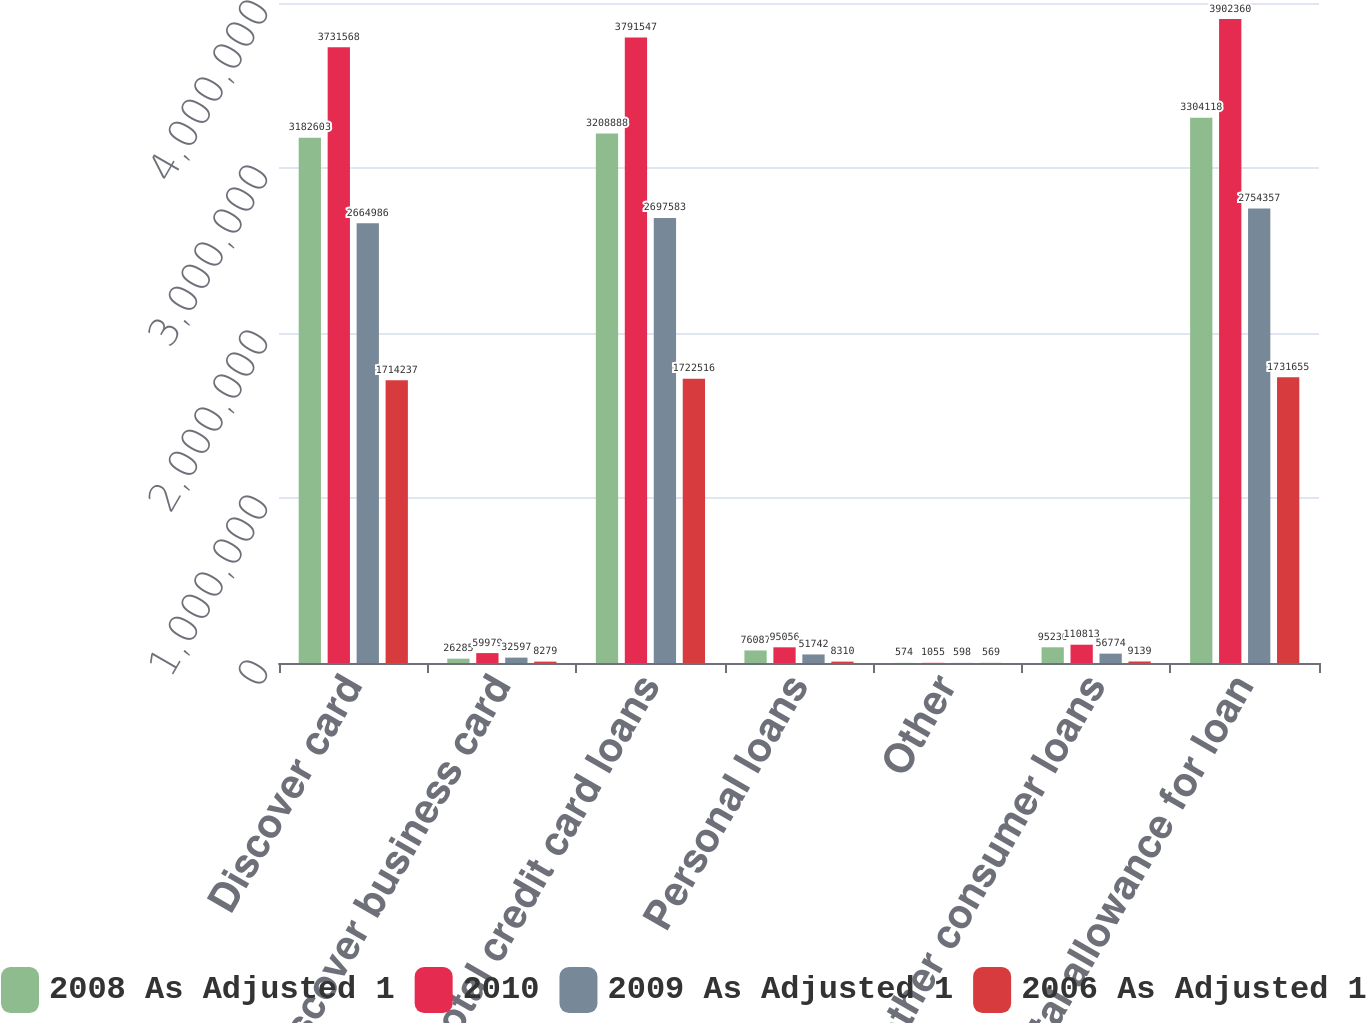Convert chart to OTSL. <chart><loc_0><loc_0><loc_500><loc_500><stacked_bar_chart><ecel><fcel>Discover card<fcel>Discover business card<fcel>Total credit card loans<fcel>Personal loans<fcel>Other<fcel>Total other consumer loans<fcel>Total allowance for loan<nl><fcel>2008 As Adjusted 1<fcel>3.1826e+06<fcel>26285<fcel>3.20889e+06<fcel>76087<fcel>574<fcel>95230<fcel>3.30412e+06<nl><fcel>2010<fcel>3.73157e+06<fcel>59979<fcel>3.79155e+06<fcel>95056<fcel>1055<fcel>110813<fcel>3.90236e+06<nl><fcel>2009 As Adjusted 1<fcel>2.66499e+06<fcel>32597<fcel>2.69758e+06<fcel>51742<fcel>598<fcel>56774<fcel>2.75436e+06<nl><fcel>2006 As Adjusted 1<fcel>1.71424e+06<fcel>8279<fcel>1.72252e+06<fcel>8310<fcel>569<fcel>9139<fcel>1.73166e+06<nl></chart> 